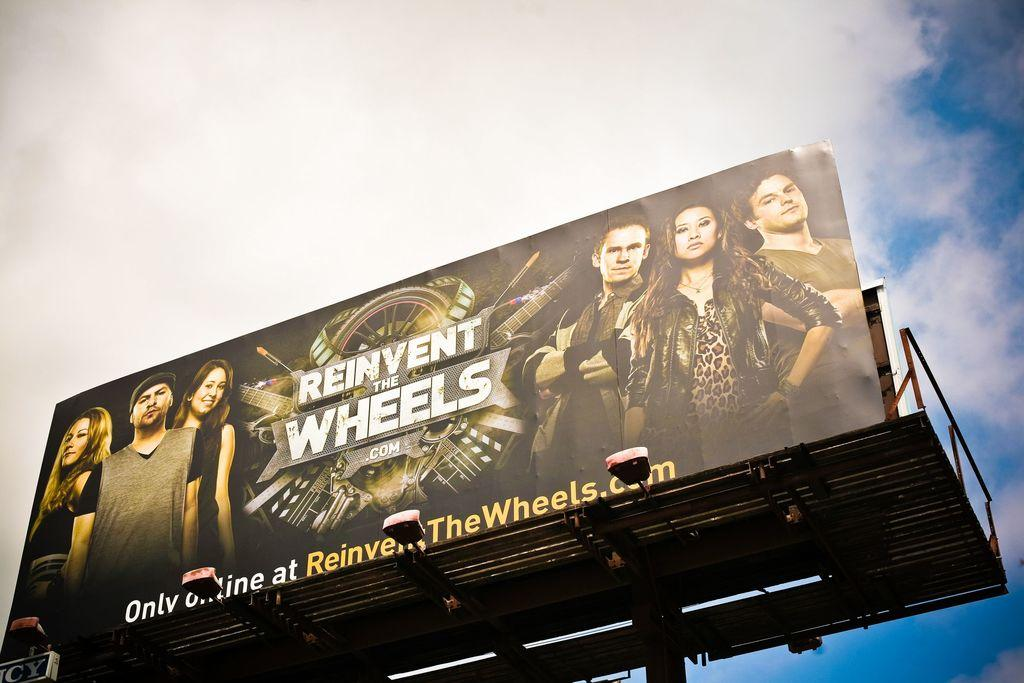<image>
Offer a succinct explanation of the picture presented. you can see a billboard labeled 'reinvent the wheels.com' 